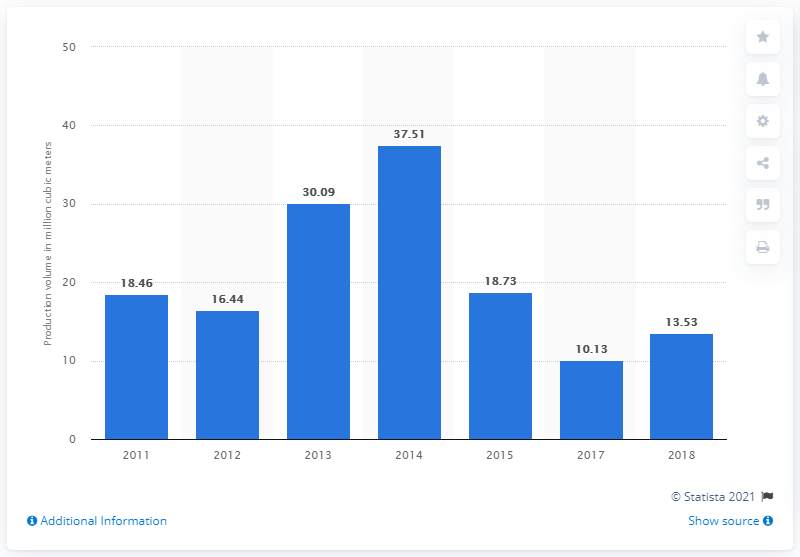Highlight a few significant elements in this photo. In 2015, a total of 18.73 cubic meters of gravel was produced in Indonesia. In 2018, a total of 13.53 cubic meters of gravel was produced in Indonesia. 